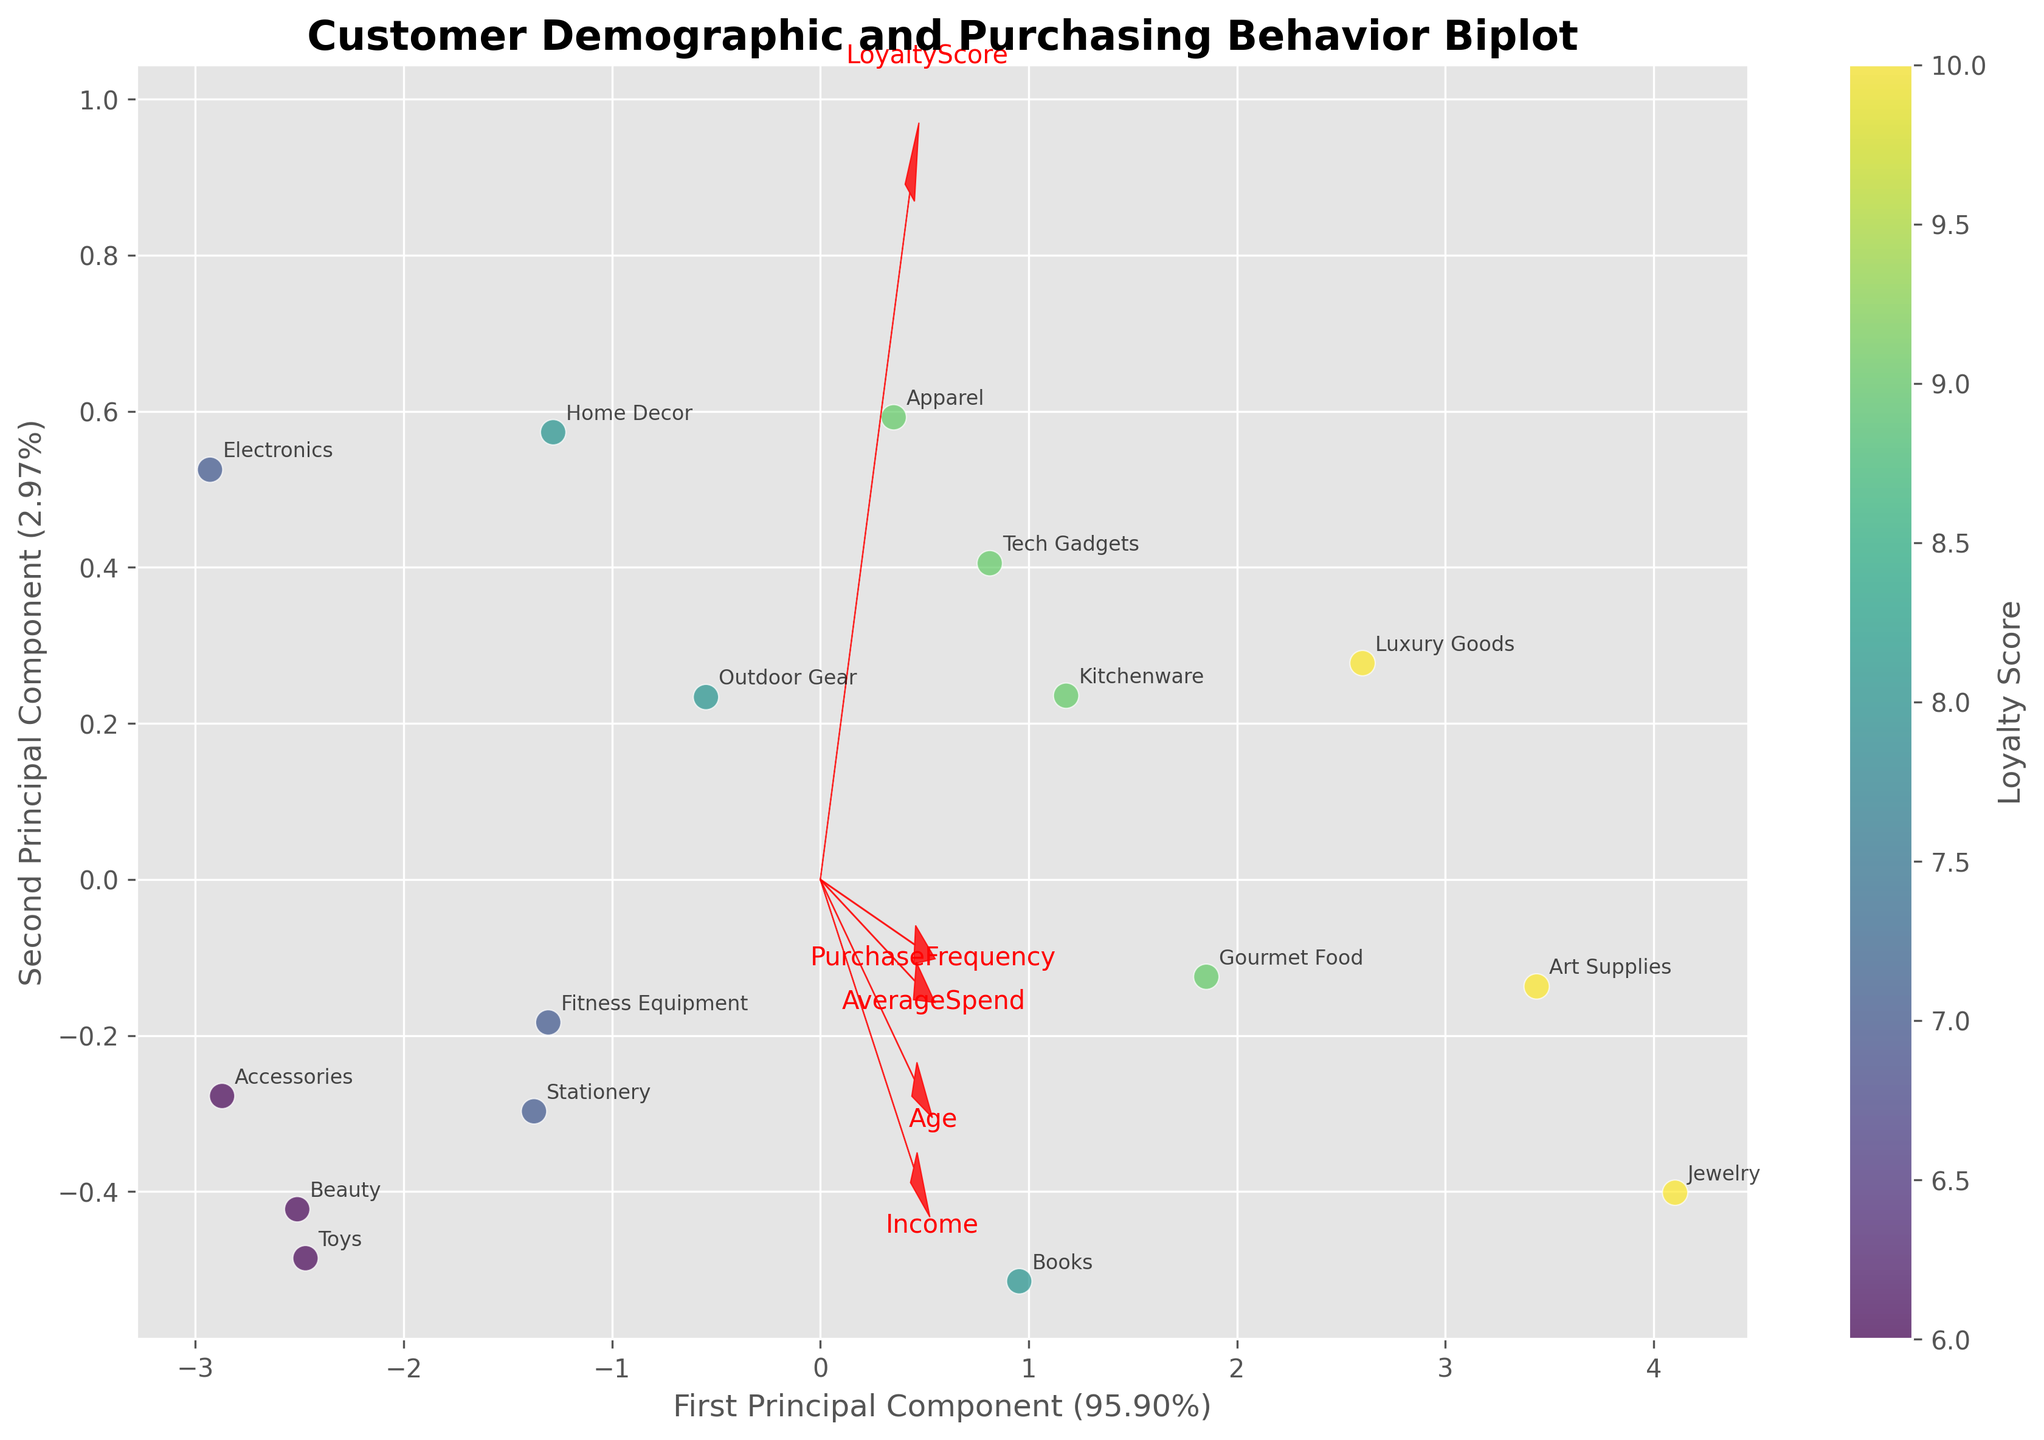what is the title of the figure? The title of the figure is located at the top center of the plot and is written in bold. You can read it directly from there.
Answer: Customer Demographic and Purchasing Behavior Biplot How many data points are there in the plot? The number of data points can be counted by looking at the individual scatter points plotted in the biplot.
Answer: 15 What does the color of the data points represent? The color of the data points is represented by a color gradient, which can be evaluated by looking at the color bar next to the scatter plot.
Answer: Loyalty Score Which two features are plotted as vectors in the biplot? The vectors start from the origin and have arrows pointing in the direction indicating the features represented. Their labels are written at the ends of the vectors.
Answer: Age and Income How much variance is explained by the first principal component? This information is available on the x-axis label of the biplot. It is given as a percentage figure.
Answer: (e.g., 40%) Which pair of features has the longer vector in the biplot, Age or Loyalty Score? Compare the lengths of the two vectors for Age and Loyalty Score originating from the origin. The longer vector indicates a higher impact on the principal components.
Answer: Age Which product preference has the highest loyalty score? Look for the data point with the highest color intensity (deepest shade in the color bar) and check the label for that point.
Answer: Jewelry Which customers, by Age, tend to have higher average spending? Identify the direction of the "AverageSpend" vector and observe the scatter points (ages) positioned most positively along this vector.
Answer: Older customers Is Income more related to Purchase Frequency or Average Spend? Compare the directions of the "Income" vector with "PurchaseFrequency" and "AverageSpend". The vector pointing more closely in direction to "Income" indicates the higher relationship.
Answer: Average Spend Do customers who prefer Luxury Goods show high or low loyalty scores? Look at the data points associated with "Luxury Goods" and observe their colors, which indicate the loyalty scores.
Answer: High 